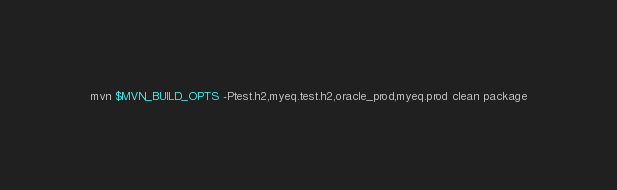<code> <loc_0><loc_0><loc_500><loc_500><_Bash_>mvn $MVN_BUILD_OPTS -Ptest.h2,myeq.test.h2,oracle_prod,myeq.prod clean package
</code> 